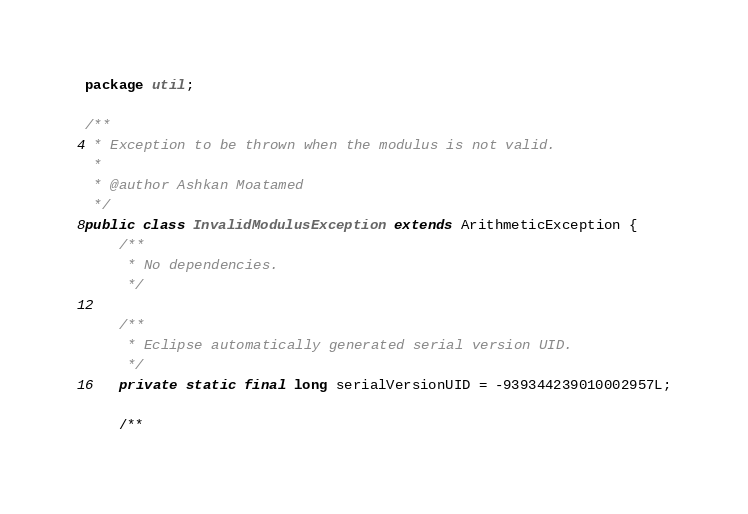Convert code to text. <code><loc_0><loc_0><loc_500><loc_500><_Java_>package util;

/**
 * Exception to be thrown when the modulus is not valid.
 * 
 * @author Ashkan Moatamed
 */
public class InvalidModulusException extends ArithmeticException {
	/**
	 * No dependencies.
	 */

	/**
	 * Eclipse automatically generated serial version UID.
	 */
	private static final long serialVersionUID = -939344239010002957L;

	/**</code> 